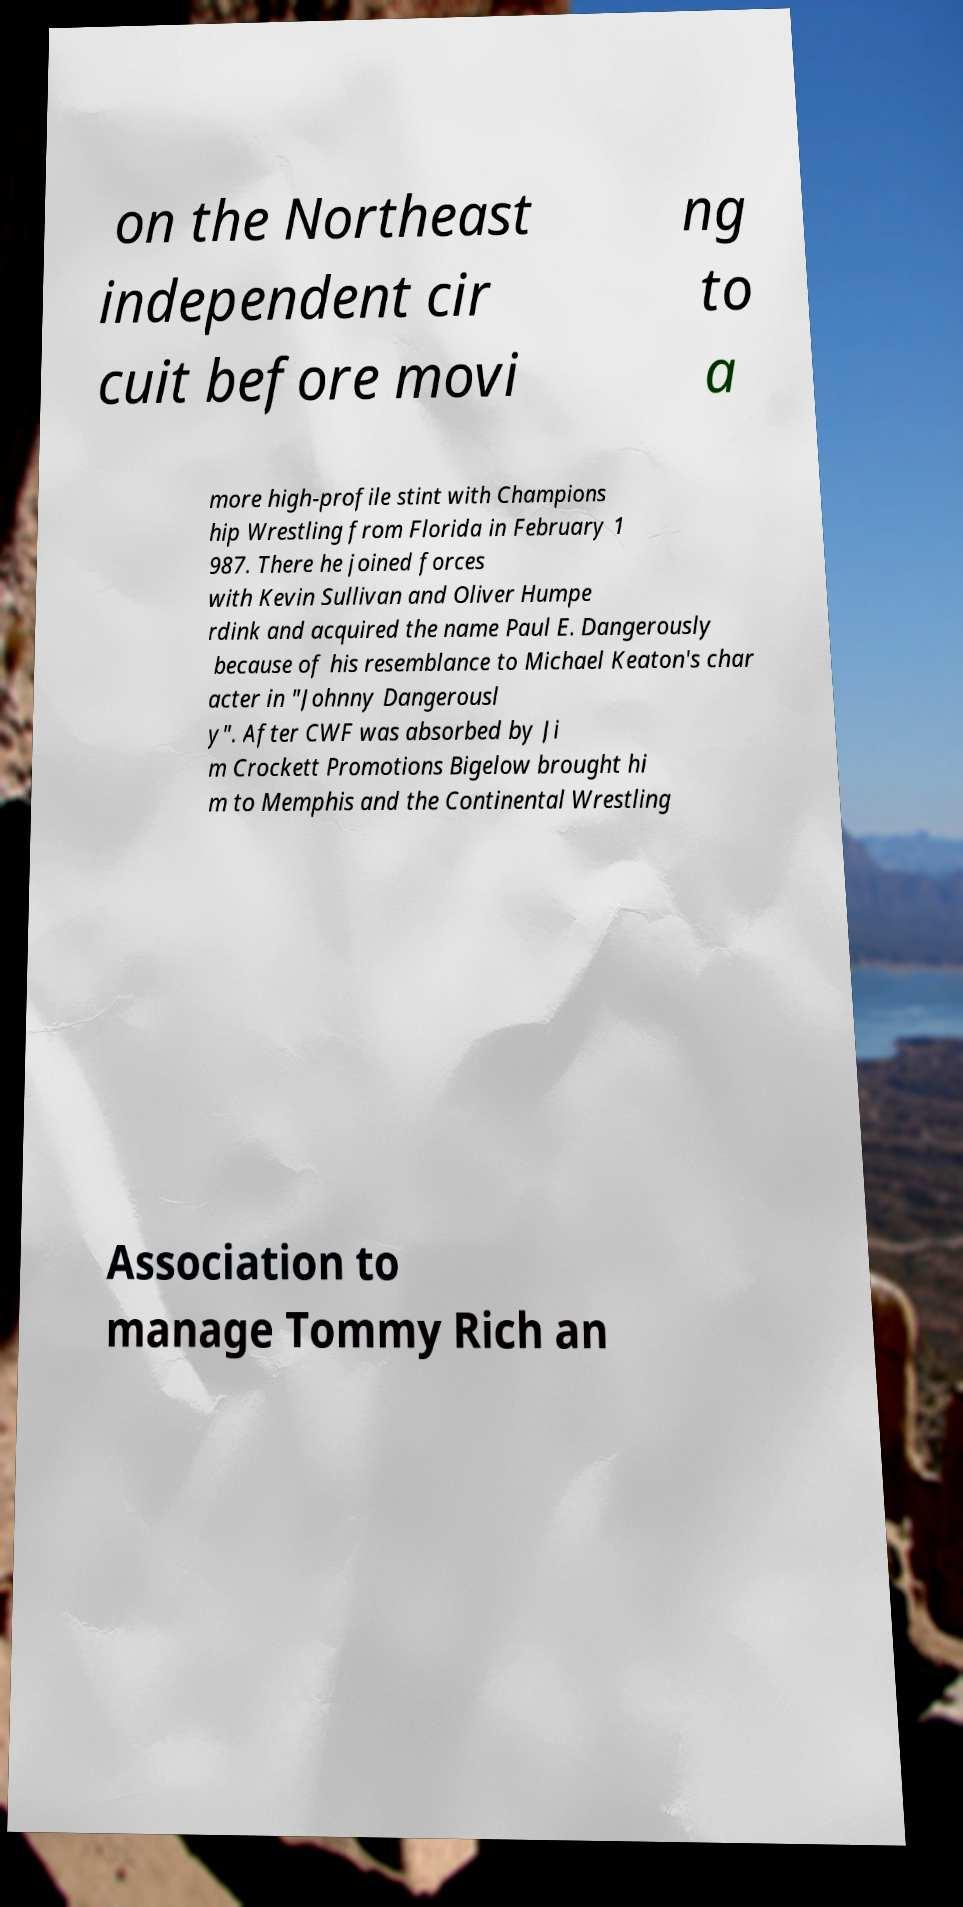For documentation purposes, I need the text within this image transcribed. Could you provide that? on the Northeast independent cir cuit before movi ng to a more high-profile stint with Champions hip Wrestling from Florida in February 1 987. There he joined forces with Kevin Sullivan and Oliver Humpe rdink and acquired the name Paul E. Dangerously because of his resemblance to Michael Keaton's char acter in "Johnny Dangerousl y". After CWF was absorbed by Ji m Crockett Promotions Bigelow brought hi m to Memphis and the Continental Wrestling Association to manage Tommy Rich an 